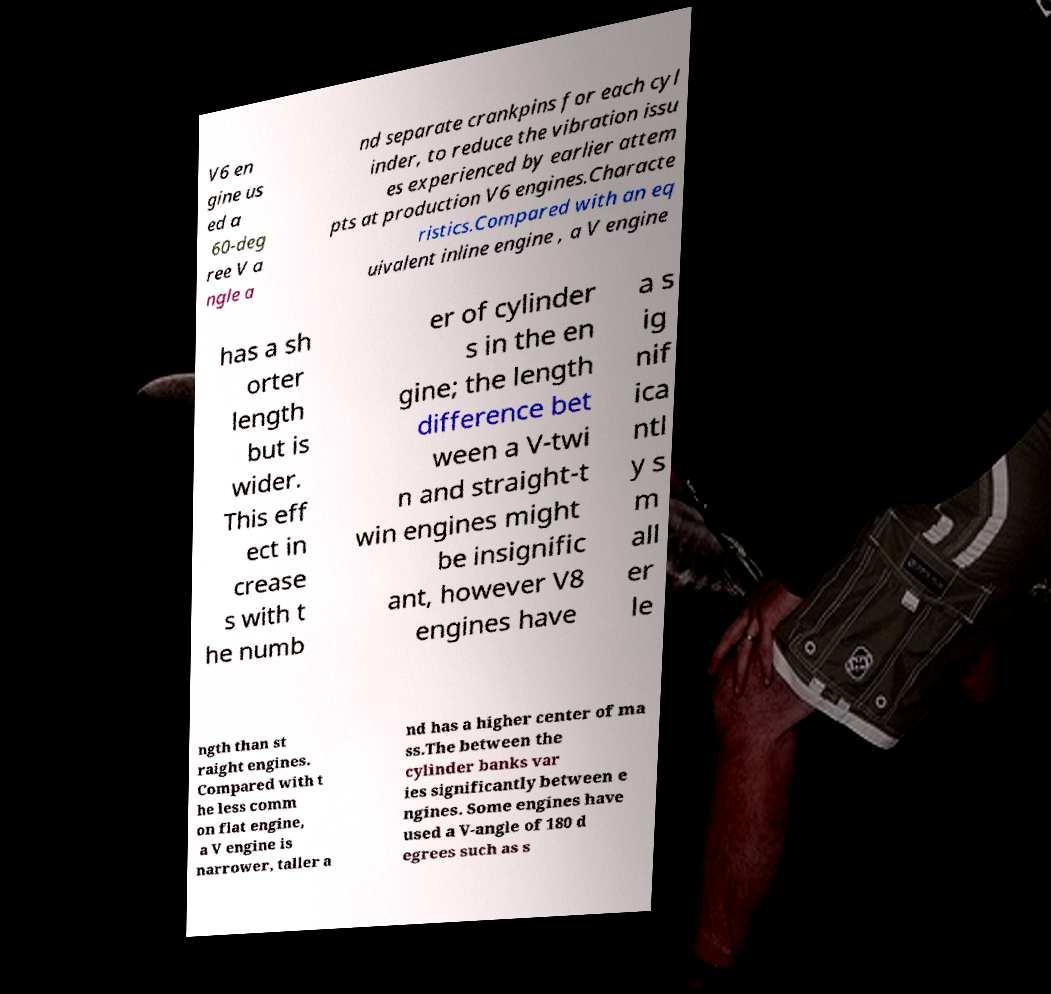For documentation purposes, I need the text within this image transcribed. Could you provide that? V6 en gine us ed a 60-deg ree V a ngle a nd separate crankpins for each cyl inder, to reduce the vibration issu es experienced by earlier attem pts at production V6 engines.Characte ristics.Compared with an eq uivalent inline engine , a V engine has a sh orter length but is wider. This eff ect in crease s with t he numb er of cylinder s in the en gine; the length difference bet ween a V-twi n and straight-t win engines might be insignific ant, however V8 engines have a s ig nif ica ntl y s m all er le ngth than st raight engines. Compared with t he less comm on flat engine, a V engine is narrower, taller a nd has a higher center of ma ss.The between the cylinder banks var ies significantly between e ngines. Some engines have used a V-angle of 180 d egrees such as s 